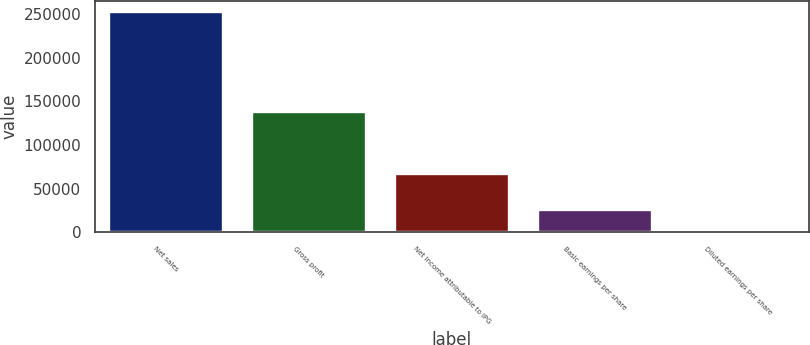Convert chart. <chart><loc_0><loc_0><loc_500><loc_500><bar_chart><fcel>Net sales<fcel>Gross profit<fcel>Net income attributable to IPG<fcel>Basic earnings per share<fcel>Diluted earnings per share<nl><fcel>252787<fcel>137703<fcel>67058<fcel>25279.8<fcel>1.25<nl></chart> 